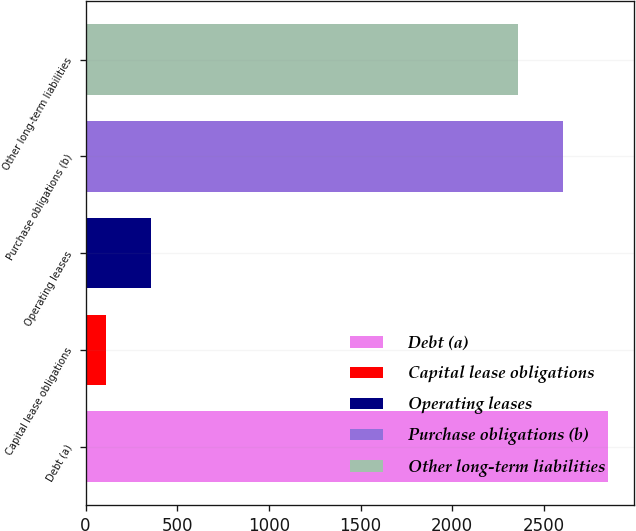Convert chart to OTSL. <chart><loc_0><loc_0><loc_500><loc_500><bar_chart><fcel>Debt (a)<fcel>Capital lease obligations<fcel>Operating leases<fcel>Purchase obligations (b)<fcel>Other long-term liabilities<nl><fcel>2848<fcel>109<fcel>355<fcel>2602<fcel>2356<nl></chart> 